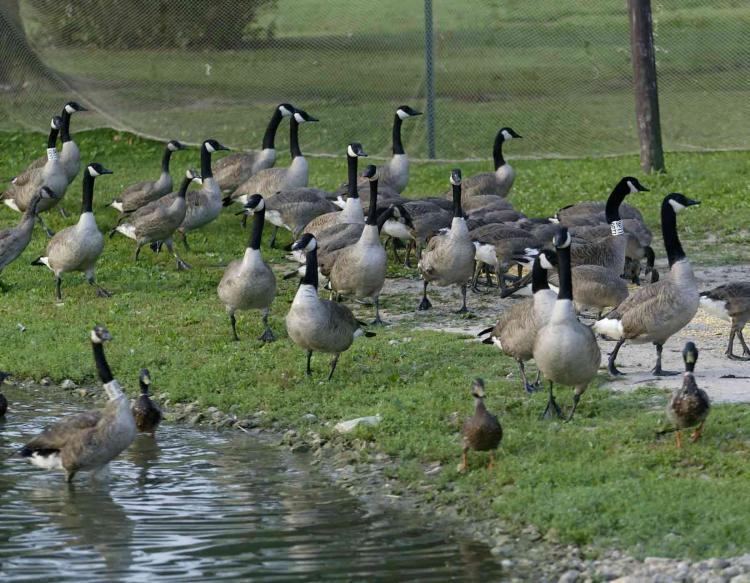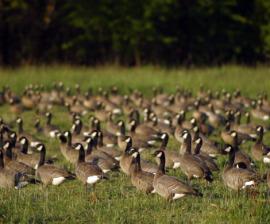The first image is the image on the left, the second image is the image on the right. Assess this claim about the two images: "One of the images shows at least one cow standing in a field behind a flock of geese.". Correct or not? Answer yes or no. No. The first image is the image on the left, the second image is the image on the right. For the images displayed, is the sentence "An image includes at least one cow standing behind a flock of birds in a field." factually correct? Answer yes or no. No. 